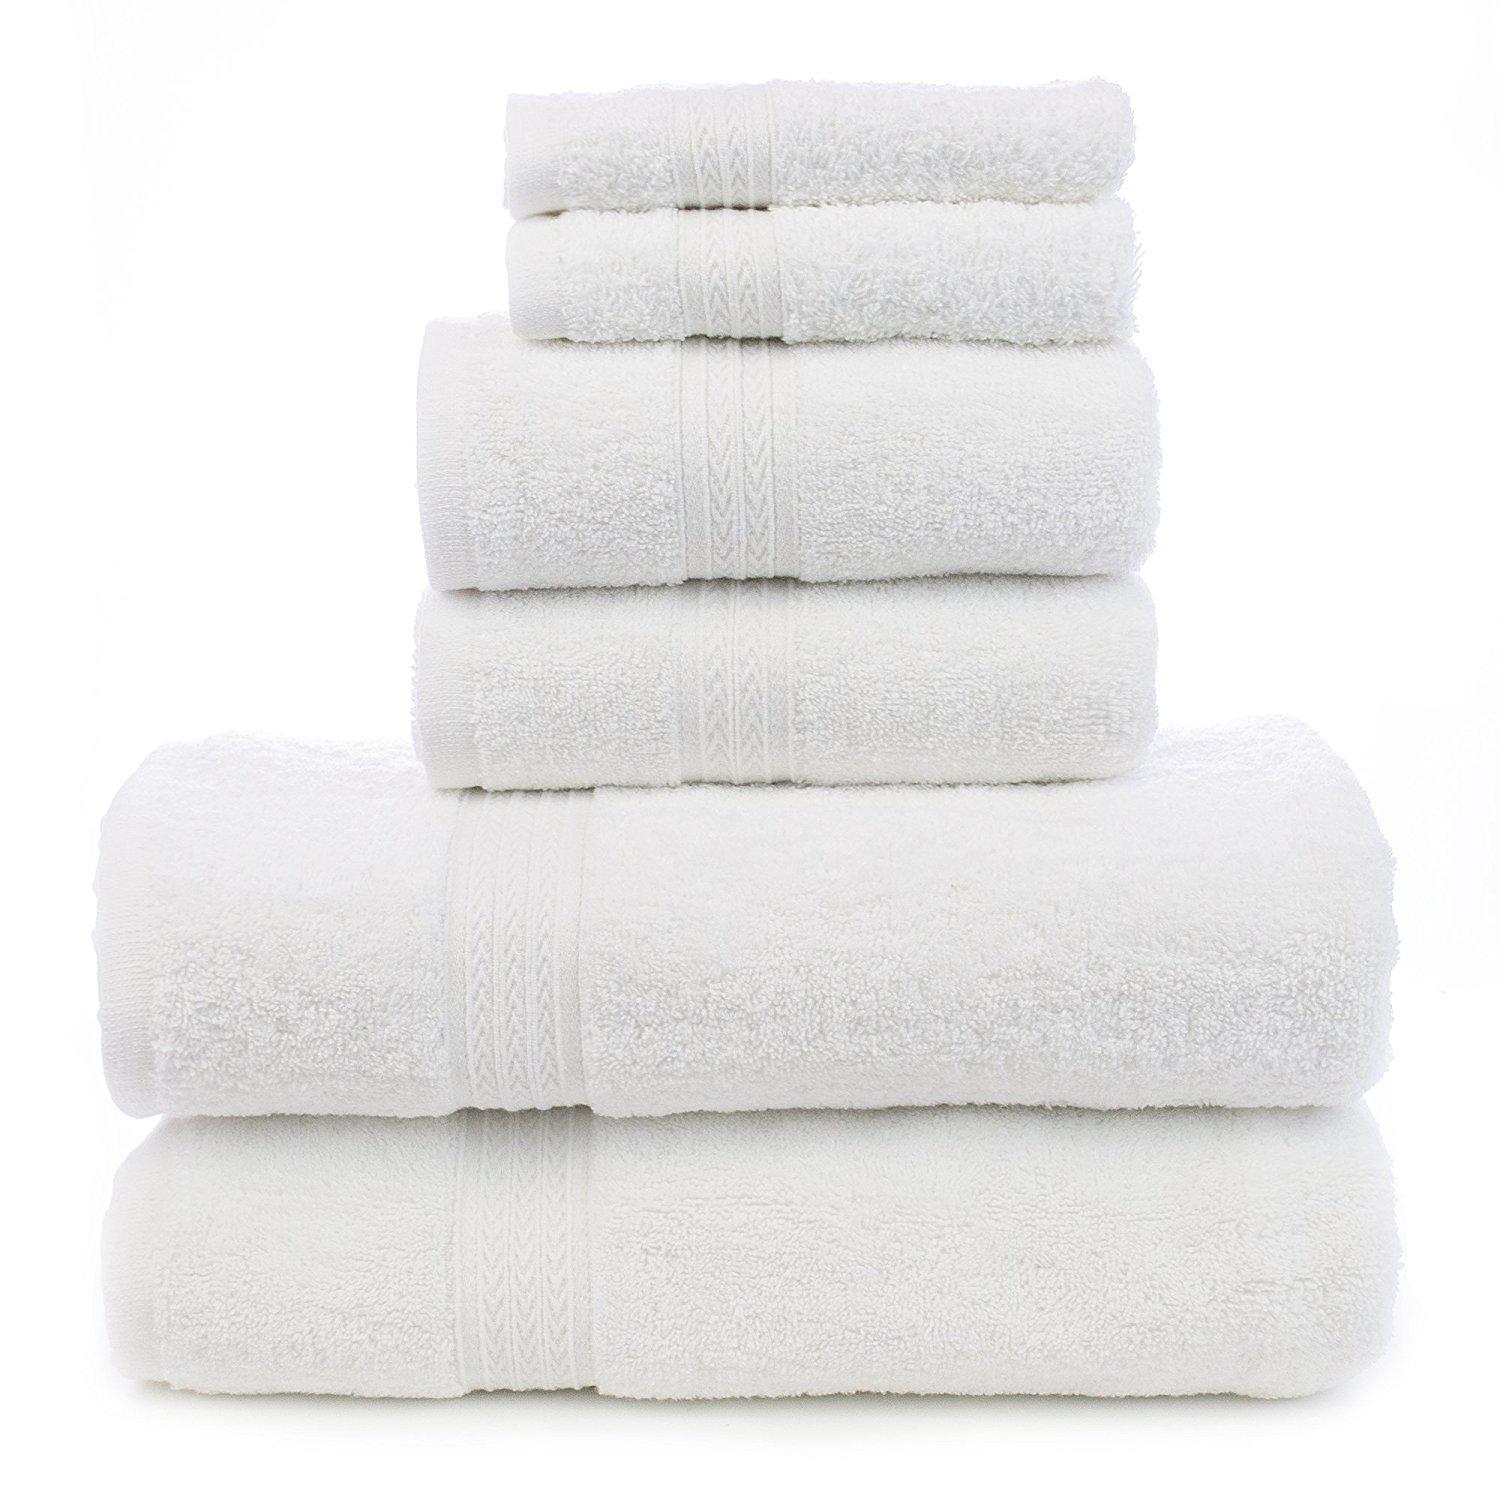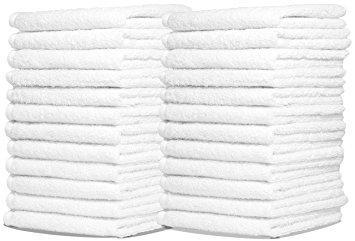The first image is the image on the left, the second image is the image on the right. For the images shown, is this caption "There are at most 6 towels shown." true? Answer yes or no. No. 